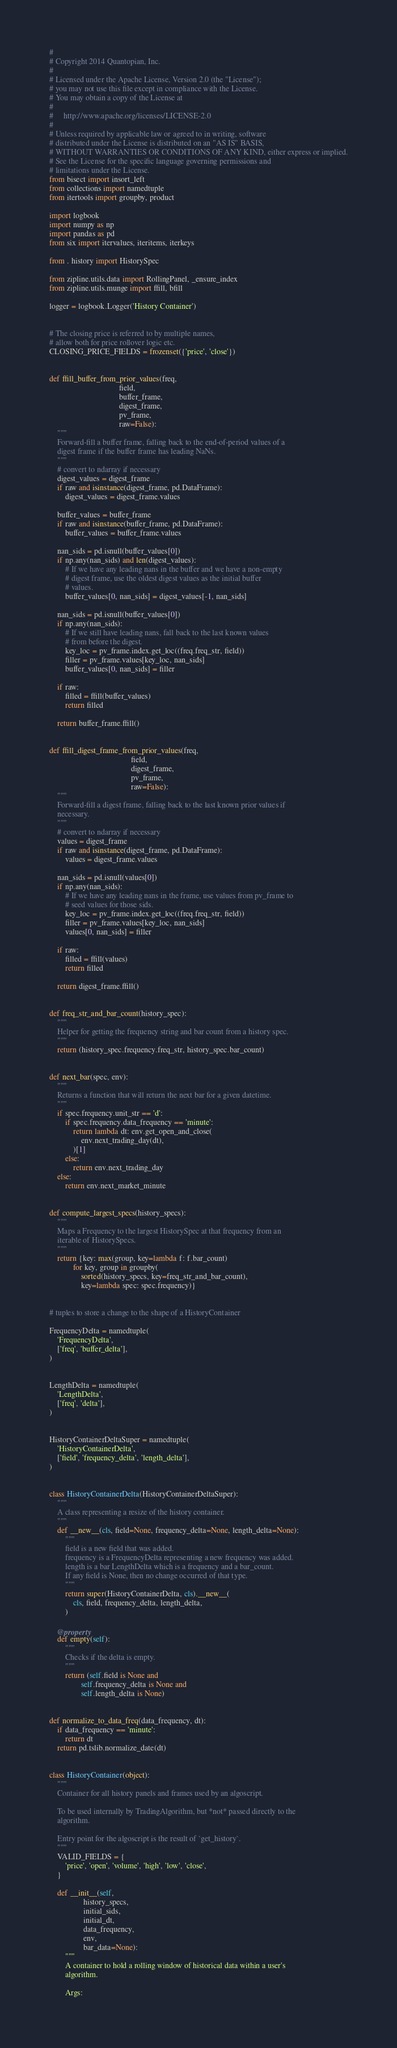Convert code to text. <code><loc_0><loc_0><loc_500><loc_500><_Python_>#
# Copyright 2014 Quantopian, Inc.
#
# Licensed under the Apache License, Version 2.0 (the "License");
# you may not use this file except in compliance with the License.
# You may obtain a copy of the License at
#
#     http://www.apache.org/licenses/LICENSE-2.0
#
# Unless required by applicable law or agreed to in writing, software
# distributed under the License is distributed on an "AS IS" BASIS,
# WITHOUT WARRANTIES OR CONDITIONS OF ANY KIND, either express or implied.
# See the License for the specific language governing permissions and
# limitations under the License.
from bisect import insort_left
from collections import namedtuple
from itertools import groupby, product

import logbook
import numpy as np
import pandas as pd
from six import itervalues, iteritems, iterkeys

from . history import HistorySpec

from zipline.utils.data import RollingPanel, _ensure_index
from zipline.utils.munge import ffill, bfill

logger = logbook.Logger('History Container')


# The closing price is referred to by multiple names,
# allow both for price rollover logic etc.
CLOSING_PRICE_FIELDS = frozenset({'price', 'close'})


def ffill_buffer_from_prior_values(freq,
                                   field,
                                   buffer_frame,
                                   digest_frame,
                                   pv_frame,
                                   raw=False):
    """
    Forward-fill a buffer frame, falling back to the end-of-period values of a
    digest frame if the buffer frame has leading NaNs.
    """
    # convert to ndarray if necessary
    digest_values = digest_frame
    if raw and isinstance(digest_frame, pd.DataFrame):
        digest_values = digest_frame.values

    buffer_values = buffer_frame
    if raw and isinstance(buffer_frame, pd.DataFrame):
        buffer_values = buffer_frame.values

    nan_sids = pd.isnull(buffer_values[0])
    if np.any(nan_sids) and len(digest_values):
        # If we have any leading nans in the buffer and we have a non-empty
        # digest frame, use the oldest digest values as the initial buffer
        # values.
        buffer_values[0, nan_sids] = digest_values[-1, nan_sids]

    nan_sids = pd.isnull(buffer_values[0])
    if np.any(nan_sids):
        # If we still have leading nans, fall back to the last known values
        # from before the digest.
        key_loc = pv_frame.index.get_loc((freq.freq_str, field))
        filler = pv_frame.values[key_loc, nan_sids]
        buffer_values[0, nan_sids] = filler

    if raw:
        filled = ffill(buffer_values)
        return filled

    return buffer_frame.ffill()


def ffill_digest_frame_from_prior_values(freq,
                                         field,
                                         digest_frame,
                                         pv_frame,
                                         raw=False):
    """
    Forward-fill a digest frame, falling back to the last known prior values if
    necessary.
    """
    # convert to ndarray if necessary
    values = digest_frame
    if raw and isinstance(digest_frame, pd.DataFrame):
        values = digest_frame.values

    nan_sids = pd.isnull(values[0])
    if np.any(nan_sids):
        # If we have any leading nans in the frame, use values from pv_frame to
        # seed values for those sids.
        key_loc = pv_frame.index.get_loc((freq.freq_str, field))
        filler = pv_frame.values[key_loc, nan_sids]
        values[0, nan_sids] = filler

    if raw:
        filled = ffill(values)
        return filled

    return digest_frame.ffill()


def freq_str_and_bar_count(history_spec):
    """
    Helper for getting the frequency string and bar count from a history spec.
    """
    return (history_spec.frequency.freq_str, history_spec.bar_count)


def next_bar(spec, env):
    """
    Returns a function that will return the next bar for a given datetime.
    """
    if spec.frequency.unit_str == 'd':
        if spec.frequency.data_frequency == 'minute':
            return lambda dt: env.get_open_and_close(
                env.next_trading_day(dt),
            )[1]
        else:
            return env.next_trading_day
    else:
        return env.next_market_minute


def compute_largest_specs(history_specs):
    """
    Maps a Frequency to the largest HistorySpec at that frequency from an
    iterable of HistorySpecs.
    """
    return {key: max(group, key=lambda f: f.bar_count)
            for key, group in groupby(
                sorted(history_specs, key=freq_str_and_bar_count),
                key=lambda spec: spec.frequency)}


# tuples to store a change to the shape of a HistoryContainer

FrequencyDelta = namedtuple(
    'FrequencyDelta',
    ['freq', 'buffer_delta'],
)


LengthDelta = namedtuple(
    'LengthDelta',
    ['freq', 'delta'],
)


HistoryContainerDeltaSuper = namedtuple(
    'HistoryContainerDelta',
    ['field', 'frequency_delta', 'length_delta'],
)


class HistoryContainerDelta(HistoryContainerDeltaSuper):
    """
    A class representing a resize of the history container.
    """
    def __new__(cls, field=None, frequency_delta=None, length_delta=None):
        """
        field is a new field that was added.
        frequency is a FrequencyDelta representing a new frequency was added.
        length is a bar LengthDelta which is a frequency and a bar_count.
        If any field is None, then no change occurred of that type.
        """
        return super(HistoryContainerDelta, cls).__new__(
            cls, field, frequency_delta, length_delta,
        )

    @property
    def empty(self):
        """
        Checks if the delta is empty.
        """
        return (self.field is None and
                self.frequency_delta is None and
                self.length_delta is None)


def normalize_to_data_freq(data_frequency, dt):
    if data_frequency == 'minute':
        return dt
    return pd.tslib.normalize_date(dt)


class HistoryContainer(object):
    """
    Container for all history panels and frames used by an algoscript.

    To be used internally by TradingAlgorithm, but *not* passed directly to the
    algorithm.

    Entry point for the algoscript is the result of `get_history`.
    """
    VALID_FIELDS = {
        'price', 'open', 'volume', 'high', 'low', 'close',
    }

    def __init__(self,
                 history_specs,
                 initial_sids,
                 initial_dt,
                 data_frequency,
                 env,
                 bar_data=None):
        """
        A container to hold a rolling window of historical data within a user's
        algorithm.

        Args:</code> 